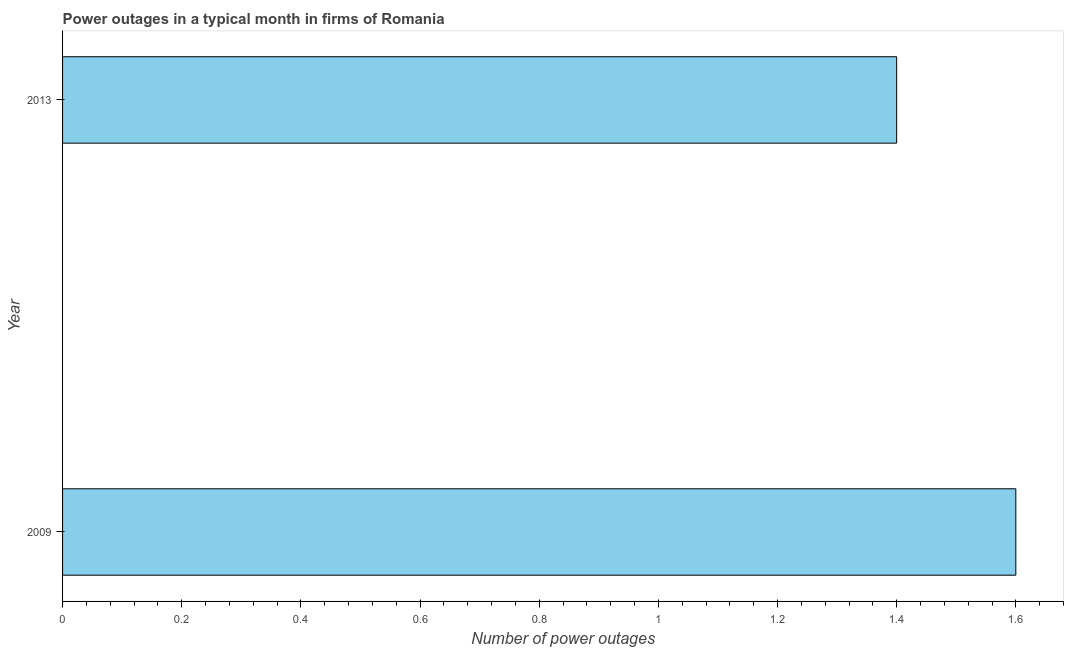Does the graph contain any zero values?
Offer a very short reply. No. What is the title of the graph?
Your response must be concise. Power outages in a typical month in firms of Romania. What is the label or title of the X-axis?
Keep it short and to the point. Number of power outages. What is the number of power outages in 2013?
Provide a succinct answer. 1.4. What is the sum of the number of power outages?
Your answer should be compact. 3. In how many years, is the number of power outages greater than 1.04 ?
Make the answer very short. 2. What is the ratio of the number of power outages in 2009 to that in 2013?
Make the answer very short. 1.14. In how many years, is the number of power outages greater than the average number of power outages taken over all years?
Keep it short and to the point. 1. Are all the bars in the graph horizontal?
Ensure brevity in your answer.  Yes. Are the values on the major ticks of X-axis written in scientific E-notation?
Keep it short and to the point. No. What is the Number of power outages of 2013?
Offer a terse response. 1.4. What is the difference between the Number of power outages in 2009 and 2013?
Your answer should be very brief. 0.2. What is the ratio of the Number of power outages in 2009 to that in 2013?
Keep it short and to the point. 1.14. 